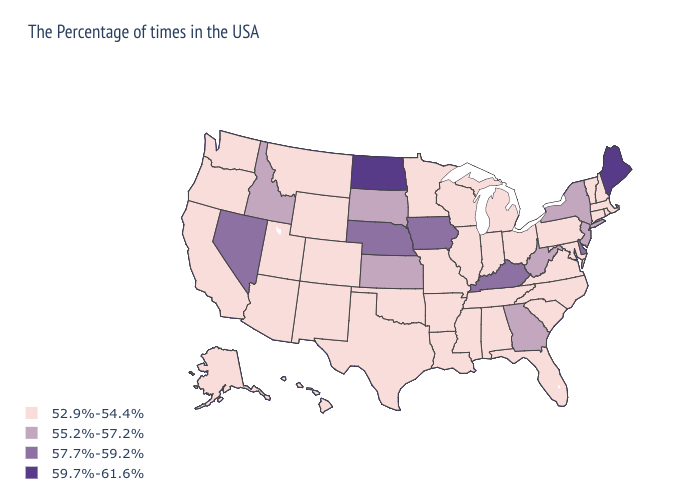Name the states that have a value in the range 57.7%-59.2%?
Quick response, please. Delaware, Kentucky, Iowa, Nebraska, Nevada. Does Utah have the highest value in the West?
Keep it brief. No. Among the states that border Idaho , does Oregon have the highest value?
Short answer required. No. Which states have the lowest value in the USA?
Give a very brief answer. Massachusetts, Rhode Island, New Hampshire, Vermont, Connecticut, Maryland, Pennsylvania, Virginia, North Carolina, South Carolina, Ohio, Florida, Michigan, Indiana, Alabama, Tennessee, Wisconsin, Illinois, Mississippi, Louisiana, Missouri, Arkansas, Minnesota, Oklahoma, Texas, Wyoming, Colorado, New Mexico, Utah, Montana, Arizona, California, Washington, Oregon, Alaska, Hawaii. Name the states that have a value in the range 57.7%-59.2%?
Answer briefly. Delaware, Kentucky, Iowa, Nebraska, Nevada. What is the value of North Carolina?
Write a very short answer. 52.9%-54.4%. Does Georgia have the lowest value in the USA?
Concise answer only. No. Which states have the lowest value in the USA?
Write a very short answer. Massachusetts, Rhode Island, New Hampshire, Vermont, Connecticut, Maryland, Pennsylvania, Virginia, North Carolina, South Carolina, Ohio, Florida, Michigan, Indiana, Alabama, Tennessee, Wisconsin, Illinois, Mississippi, Louisiana, Missouri, Arkansas, Minnesota, Oklahoma, Texas, Wyoming, Colorado, New Mexico, Utah, Montana, Arizona, California, Washington, Oregon, Alaska, Hawaii. What is the highest value in the MidWest ?
Quick response, please. 59.7%-61.6%. Name the states that have a value in the range 55.2%-57.2%?
Be succinct. New York, New Jersey, West Virginia, Georgia, Kansas, South Dakota, Idaho. What is the value of Ohio?
Answer briefly. 52.9%-54.4%. Which states hav the highest value in the Northeast?
Concise answer only. Maine. What is the value of Connecticut?
Be succinct. 52.9%-54.4%. What is the lowest value in the USA?
Concise answer only. 52.9%-54.4%. Which states have the highest value in the USA?
Write a very short answer. Maine, North Dakota. 